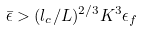Convert formula to latex. <formula><loc_0><loc_0><loc_500><loc_500>\bar { \epsilon } > ( l _ { c } / L ) ^ { 2 / 3 } K ^ { 3 } \epsilon _ { f }</formula> 